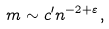Convert formula to latex. <formula><loc_0><loc_0><loc_500><loc_500>m \sim c ^ { \prime } n ^ { - 2 + \varepsilon } ,</formula> 